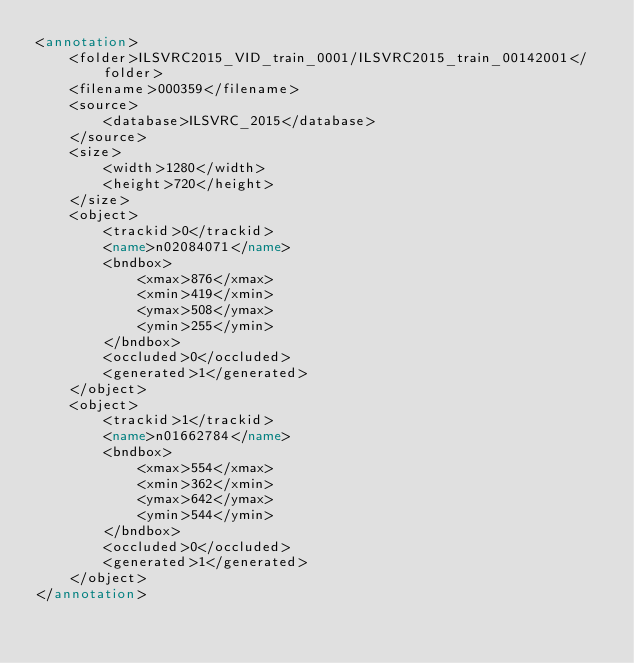<code> <loc_0><loc_0><loc_500><loc_500><_XML_><annotation>
	<folder>ILSVRC2015_VID_train_0001/ILSVRC2015_train_00142001</folder>
	<filename>000359</filename>
	<source>
		<database>ILSVRC_2015</database>
	</source>
	<size>
		<width>1280</width>
		<height>720</height>
	</size>
	<object>
		<trackid>0</trackid>
		<name>n02084071</name>
		<bndbox>
			<xmax>876</xmax>
			<xmin>419</xmin>
			<ymax>508</ymax>
			<ymin>255</ymin>
		</bndbox>
		<occluded>0</occluded>
		<generated>1</generated>
	</object>
	<object>
		<trackid>1</trackid>
		<name>n01662784</name>
		<bndbox>
			<xmax>554</xmax>
			<xmin>362</xmin>
			<ymax>642</ymax>
			<ymin>544</ymin>
		</bndbox>
		<occluded>0</occluded>
		<generated>1</generated>
	</object>
</annotation>
</code> 